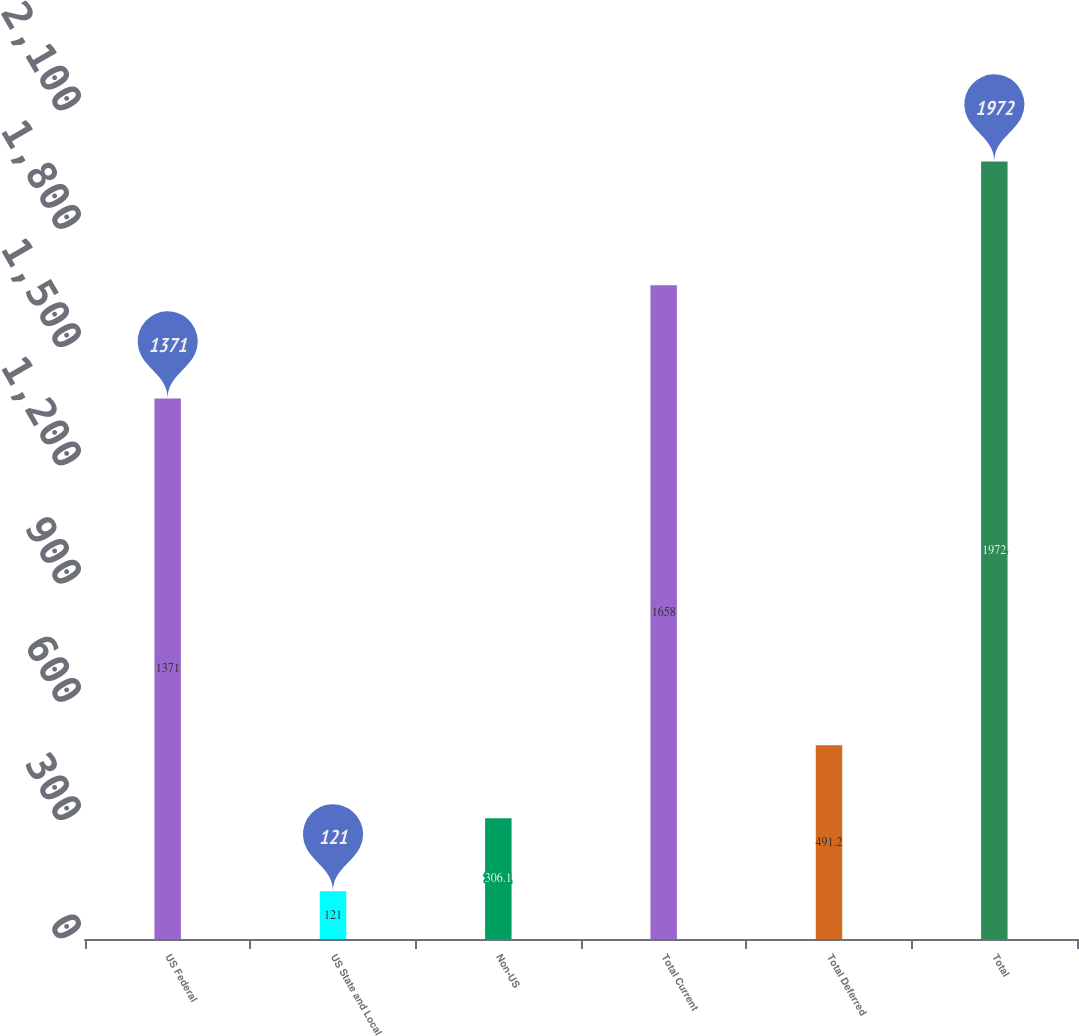Convert chart to OTSL. <chart><loc_0><loc_0><loc_500><loc_500><bar_chart><fcel>US Federal<fcel>US State and Local<fcel>Non-US<fcel>Total Current<fcel>Total Deferred<fcel>Total<nl><fcel>1371<fcel>121<fcel>306.1<fcel>1658<fcel>491.2<fcel>1972<nl></chart> 